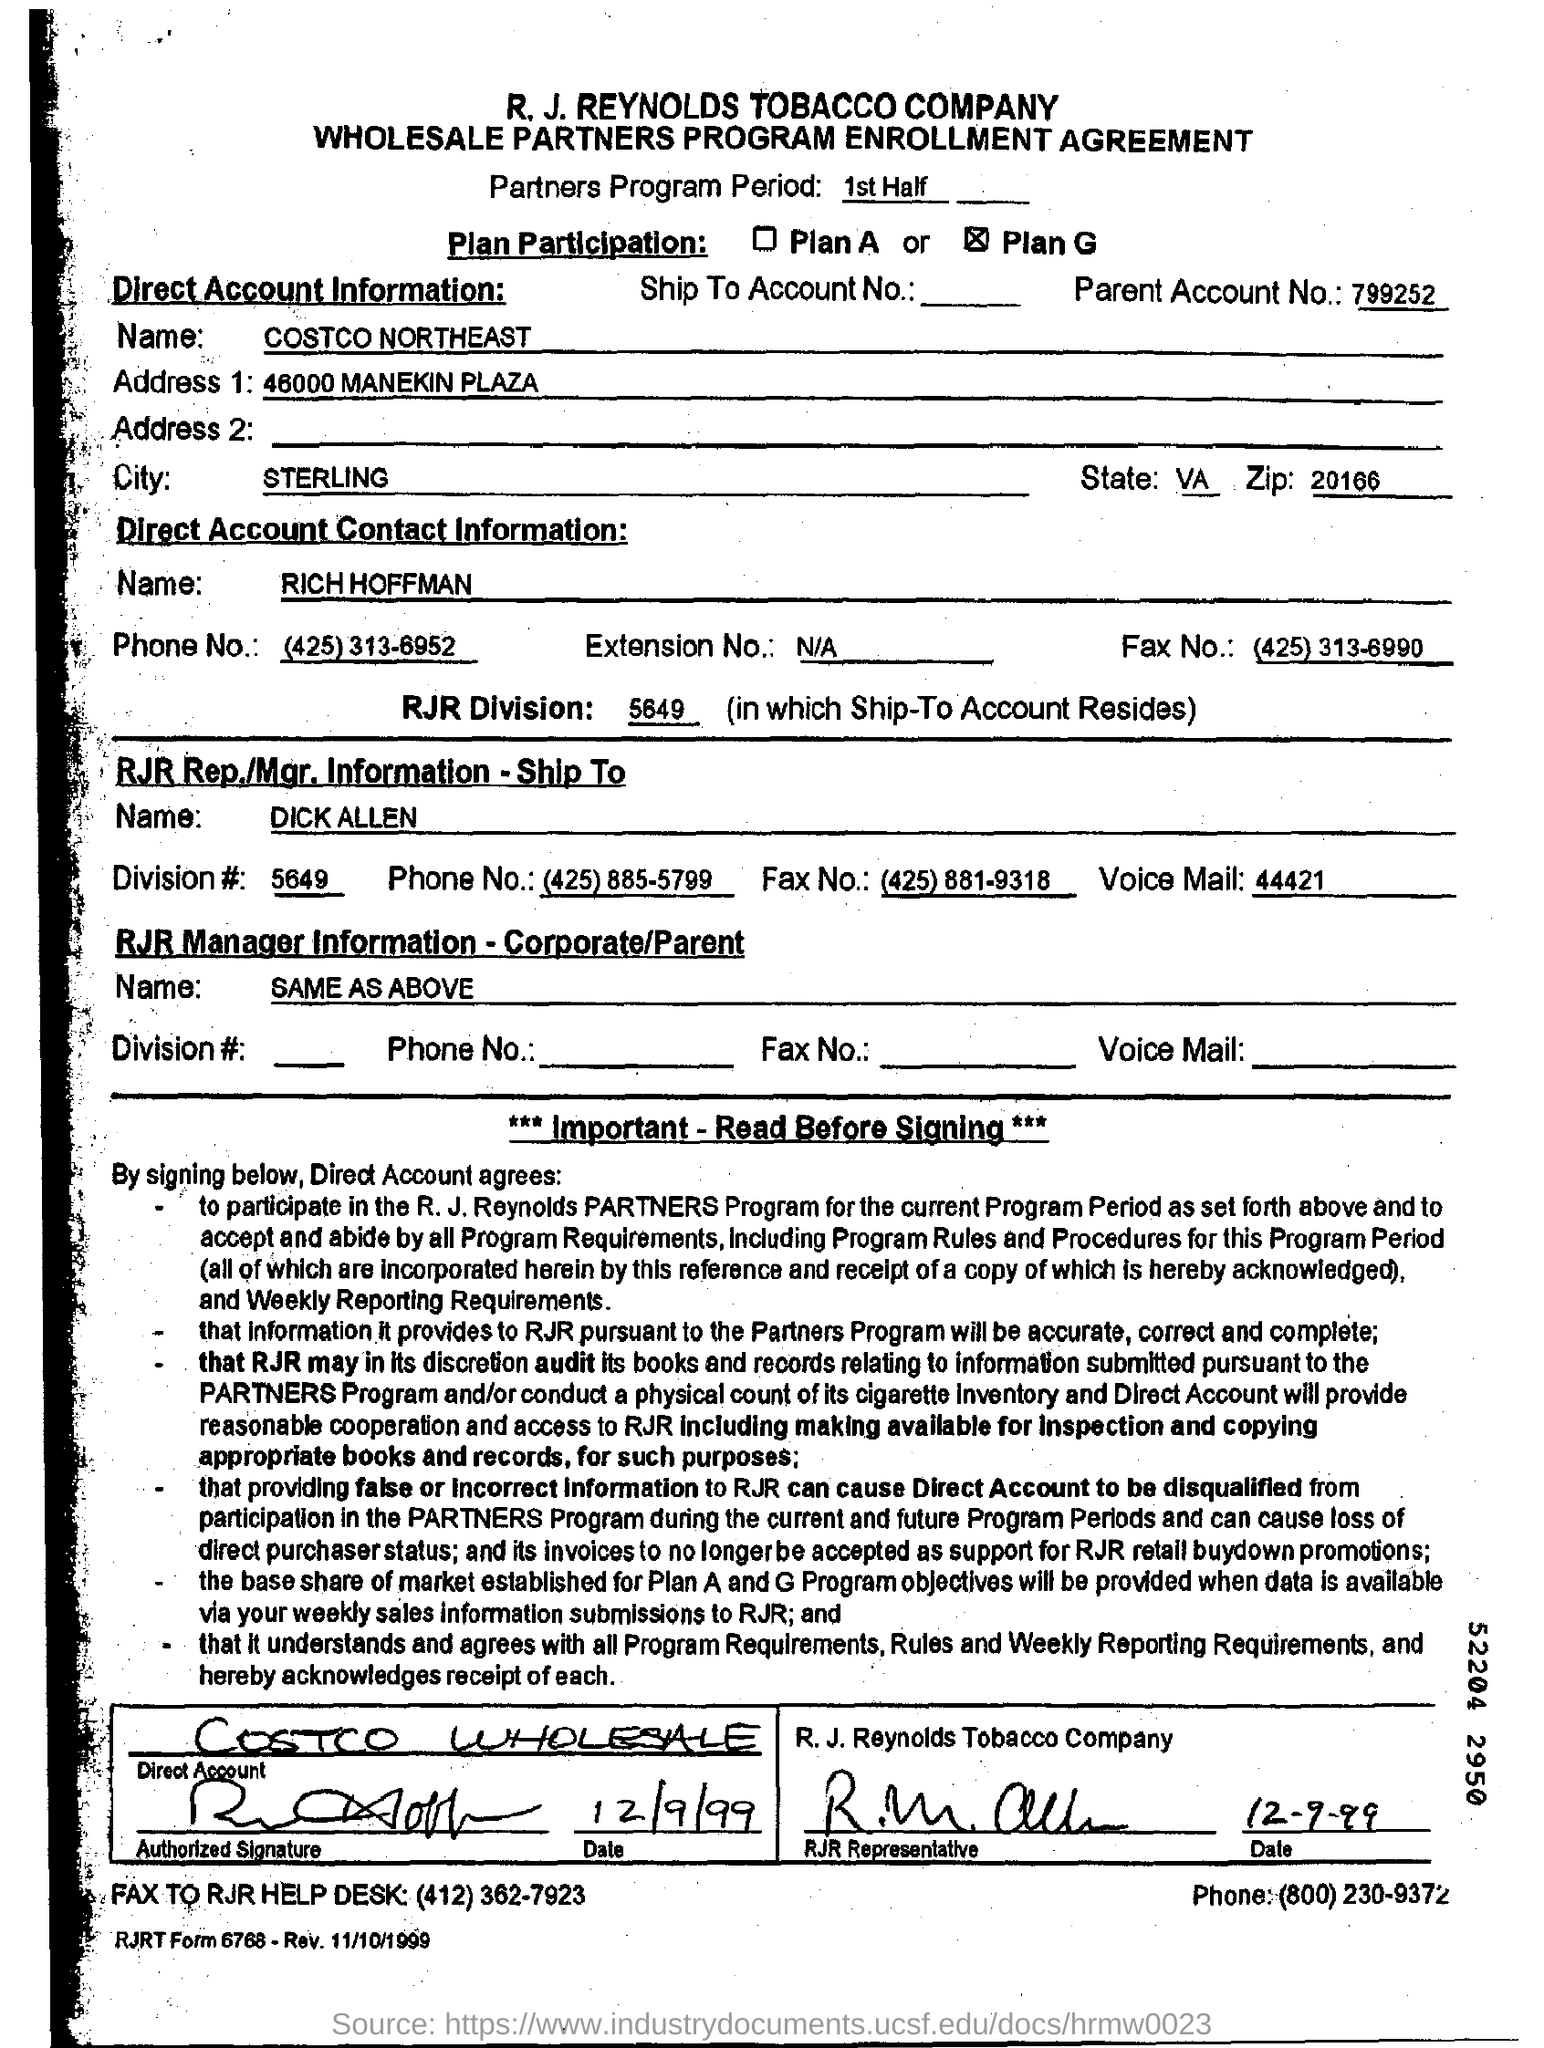What is name of RJR Rep?
Make the answer very short. DICK ALLEN. What is the name of the company?
Provide a succinct answer. R. J. REYNOLDS TOBACCO COMPANY. What sort of agreement is this as mentioned in sencond line of this page?
Ensure brevity in your answer.  WHOLESALE PARTNERS PROGRAM ENROLLMENT AGREEMENT. What is the name of the company as per direct account information ?
Provide a succinct answer. COSTCO NORTHEAST. What is the name of the city as per direct account information ?
Your response must be concise. Sterling. What is the name of the person as per direct account contact information ?
Provide a short and direct response. RICH HOFFMAN. What is RJR division no: in which ship to account resides?
Provide a short and direct response. 5649. 